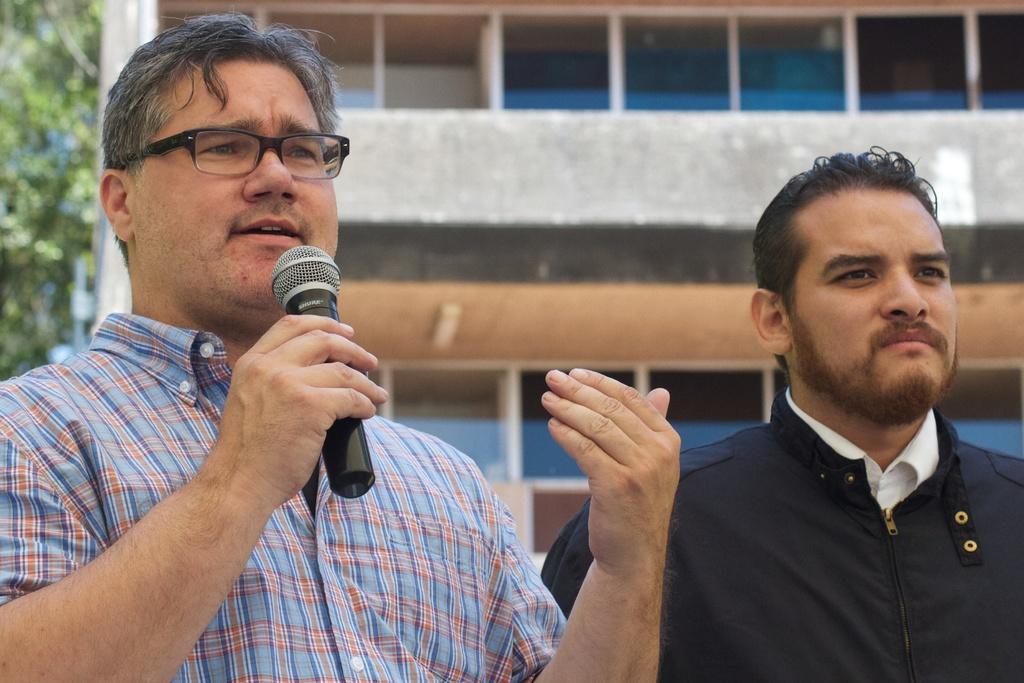Describe this image in one or two sentences. In this image there are two men standing. The man to the left is holding a microphone in his hand. Behind them there is a building. To the left there are leaves of a tree. 